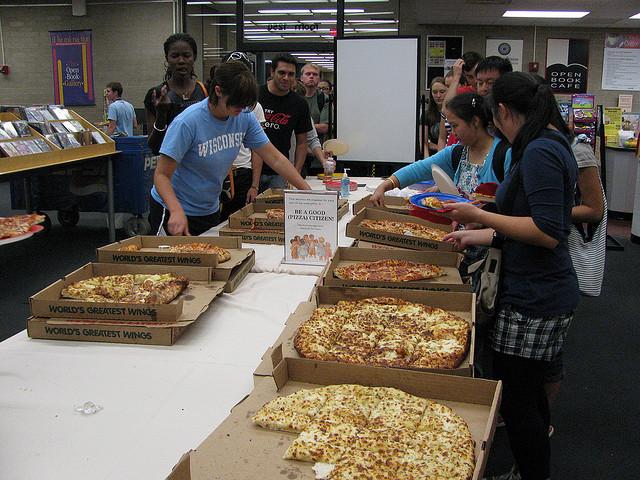How many pizzas are there?
Keep it brief. 10. Why is there only one male in this group?
Give a very brief answer. No. What is the lady making?
Concise answer only. Pizza. Are this people eating pizza?
Answer briefly. Yes. What are the people eating?
Short answer required. Pizza. 